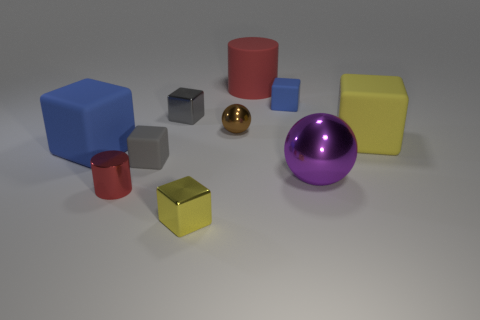Subtract all gray blocks. How many blocks are left? 4 Subtract all yellow rubber blocks. How many blocks are left? 5 Subtract all purple spheres. Subtract all blue blocks. How many spheres are left? 1 Subtract all cubes. How many objects are left? 4 Add 5 tiny gray matte cubes. How many tiny gray matte cubes exist? 6 Subtract 0 green spheres. How many objects are left? 10 Subtract all big red cylinders. Subtract all purple metal balls. How many objects are left? 8 Add 1 purple metal objects. How many purple metal objects are left? 2 